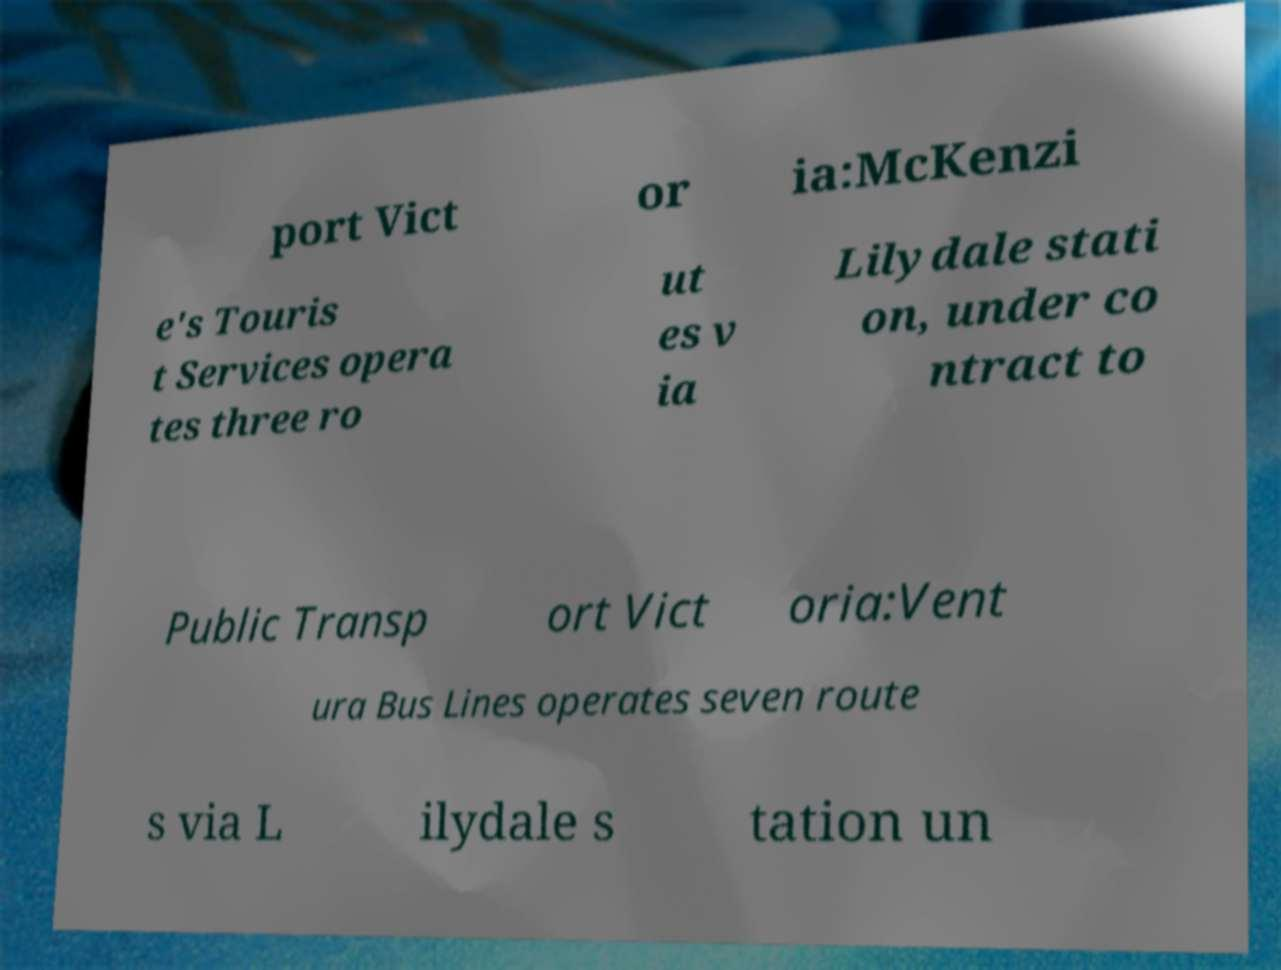There's text embedded in this image that I need extracted. Can you transcribe it verbatim? port Vict or ia:McKenzi e's Touris t Services opera tes three ro ut es v ia Lilydale stati on, under co ntract to Public Transp ort Vict oria:Vent ura Bus Lines operates seven route s via L ilydale s tation un 